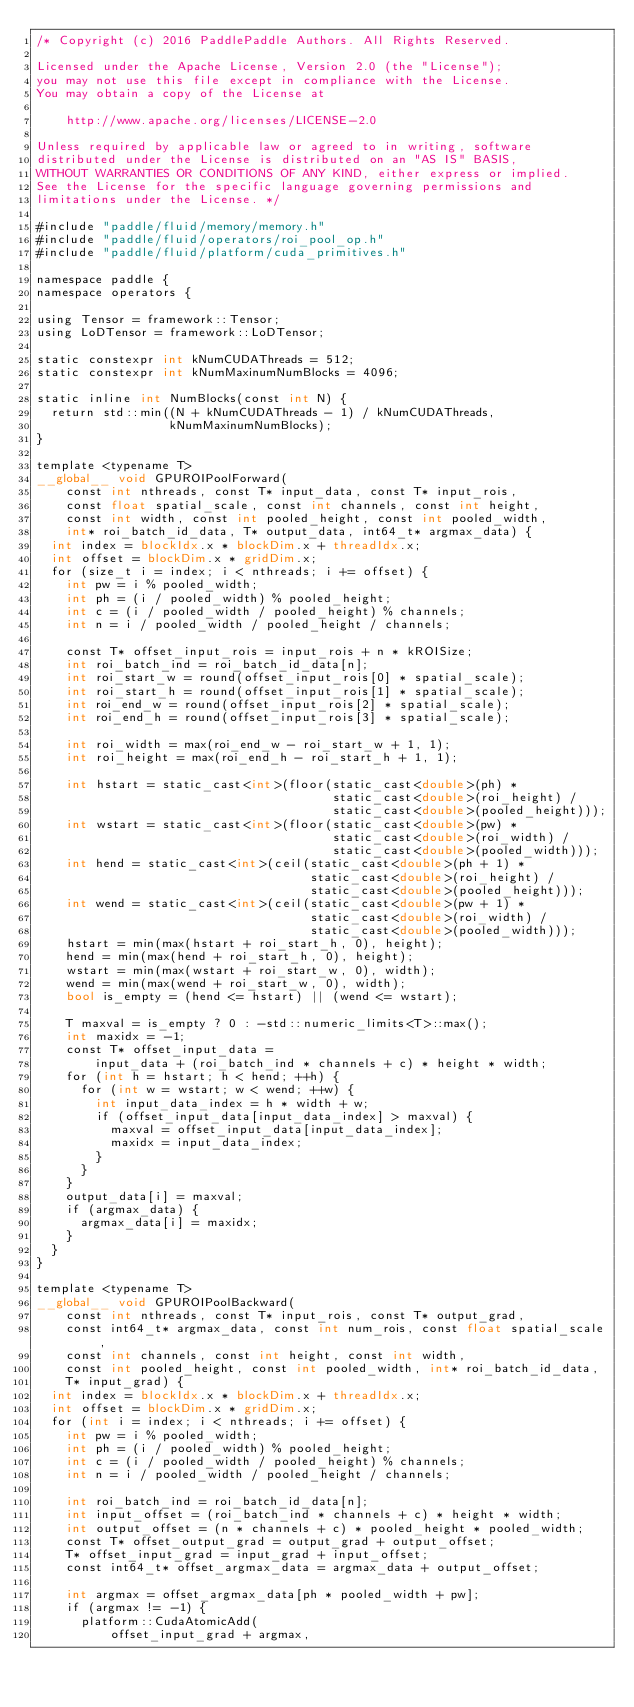<code> <loc_0><loc_0><loc_500><loc_500><_Cuda_>/* Copyright (c) 2016 PaddlePaddle Authors. All Rights Reserved.

Licensed under the Apache License, Version 2.0 (the "License");
you may not use this file except in compliance with the License.
You may obtain a copy of the License at

    http://www.apache.org/licenses/LICENSE-2.0

Unless required by applicable law or agreed to in writing, software
distributed under the License is distributed on an "AS IS" BASIS,
WITHOUT WARRANTIES OR CONDITIONS OF ANY KIND, either express or implied.
See the License for the specific language governing permissions and
limitations under the License. */

#include "paddle/fluid/memory/memory.h"
#include "paddle/fluid/operators/roi_pool_op.h"
#include "paddle/fluid/platform/cuda_primitives.h"

namespace paddle {
namespace operators {

using Tensor = framework::Tensor;
using LoDTensor = framework::LoDTensor;

static constexpr int kNumCUDAThreads = 512;
static constexpr int kNumMaxinumNumBlocks = 4096;

static inline int NumBlocks(const int N) {
  return std::min((N + kNumCUDAThreads - 1) / kNumCUDAThreads,
                  kNumMaxinumNumBlocks);
}

template <typename T>
__global__ void GPUROIPoolForward(
    const int nthreads, const T* input_data, const T* input_rois,
    const float spatial_scale, const int channels, const int height,
    const int width, const int pooled_height, const int pooled_width,
    int* roi_batch_id_data, T* output_data, int64_t* argmax_data) {
  int index = blockIdx.x * blockDim.x + threadIdx.x;
  int offset = blockDim.x * gridDim.x;
  for (size_t i = index; i < nthreads; i += offset) {
    int pw = i % pooled_width;
    int ph = (i / pooled_width) % pooled_height;
    int c = (i / pooled_width / pooled_height) % channels;
    int n = i / pooled_width / pooled_height / channels;

    const T* offset_input_rois = input_rois + n * kROISize;
    int roi_batch_ind = roi_batch_id_data[n];
    int roi_start_w = round(offset_input_rois[0] * spatial_scale);
    int roi_start_h = round(offset_input_rois[1] * spatial_scale);
    int roi_end_w = round(offset_input_rois[2] * spatial_scale);
    int roi_end_h = round(offset_input_rois[3] * spatial_scale);

    int roi_width = max(roi_end_w - roi_start_w + 1, 1);
    int roi_height = max(roi_end_h - roi_start_h + 1, 1);

    int hstart = static_cast<int>(floor(static_cast<double>(ph) *
                                        static_cast<double>(roi_height) /
                                        static_cast<double>(pooled_height)));
    int wstart = static_cast<int>(floor(static_cast<double>(pw) *
                                        static_cast<double>(roi_width) /
                                        static_cast<double>(pooled_width)));
    int hend = static_cast<int>(ceil(static_cast<double>(ph + 1) *
                                     static_cast<double>(roi_height) /
                                     static_cast<double>(pooled_height)));
    int wend = static_cast<int>(ceil(static_cast<double>(pw + 1) *
                                     static_cast<double>(roi_width) /
                                     static_cast<double>(pooled_width)));
    hstart = min(max(hstart + roi_start_h, 0), height);
    hend = min(max(hend + roi_start_h, 0), height);
    wstart = min(max(wstart + roi_start_w, 0), width);
    wend = min(max(wend + roi_start_w, 0), width);
    bool is_empty = (hend <= hstart) || (wend <= wstart);

    T maxval = is_empty ? 0 : -std::numeric_limits<T>::max();
    int maxidx = -1;
    const T* offset_input_data =
        input_data + (roi_batch_ind * channels + c) * height * width;
    for (int h = hstart; h < hend; ++h) {
      for (int w = wstart; w < wend; ++w) {
        int input_data_index = h * width + w;
        if (offset_input_data[input_data_index] > maxval) {
          maxval = offset_input_data[input_data_index];
          maxidx = input_data_index;
        }
      }
    }
    output_data[i] = maxval;
    if (argmax_data) {
      argmax_data[i] = maxidx;
    }
  }
}

template <typename T>
__global__ void GPUROIPoolBackward(
    const int nthreads, const T* input_rois, const T* output_grad,
    const int64_t* argmax_data, const int num_rois, const float spatial_scale,
    const int channels, const int height, const int width,
    const int pooled_height, const int pooled_width, int* roi_batch_id_data,
    T* input_grad) {
  int index = blockIdx.x * blockDim.x + threadIdx.x;
  int offset = blockDim.x * gridDim.x;
  for (int i = index; i < nthreads; i += offset) {
    int pw = i % pooled_width;
    int ph = (i / pooled_width) % pooled_height;
    int c = (i / pooled_width / pooled_height) % channels;
    int n = i / pooled_width / pooled_height / channels;

    int roi_batch_ind = roi_batch_id_data[n];
    int input_offset = (roi_batch_ind * channels + c) * height * width;
    int output_offset = (n * channels + c) * pooled_height * pooled_width;
    const T* offset_output_grad = output_grad + output_offset;
    T* offset_input_grad = input_grad + input_offset;
    const int64_t* offset_argmax_data = argmax_data + output_offset;

    int argmax = offset_argmax_data[ph * pooled_width + pw];
    if (argmax != -1) {
      platform::CudaAtomicAdd(
          offset_input_grad + argmax,</code> 